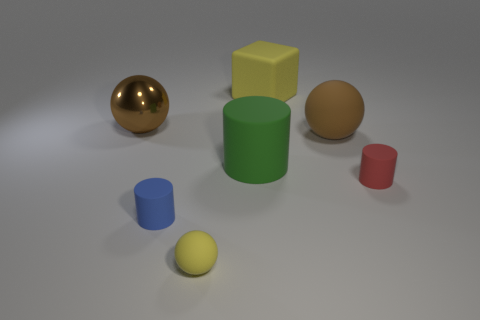What is the size of the yellow thing that is behind the brown sphere that is in front of the big shiny object?
Offer a very short reply. Large. The metallic sphere has what color?
Your response must be concise. Brown. How many small yellow spheres are in front of the big sphere to the right of the large brown metallic object?
Provide a short and direct response. 1. There is a yellow rubber object that is behind the red object; are there any cubes left of it?
Provide a short and direct response. No. Are there any blue matte things behind the tiny red object?
Your answer should be compact. No. There is a large thing on the right side of the big yellow cube; does it have the same shape as the big yellow rubber thing?
Make the answer very short. No. How many green things are the same shape as the small yellow object?
Make the answer very short. 0. Are there any yellow objects made of the same material as the small blue thing?
Offer a terse response. Yes. What is the material of the yellow object that is behind the tiny rubber cylinder on the right side of the yellow sphere?
Ensure brevity in your answer.  Rubber. How big is the brown object that is to the right of the big green matte cylinder?
Offer a very short reply. Large. 